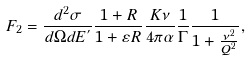Convert formula to latex. <formula><loc_0><loc_0><loc_500><loc_500>F _ { 2 } = \frac { d ^ { 2 } \sigma } { d \Omega d E ^ { ^ { \prime } } } \frac { 1 + R } { 1 + \varepsilon R } \frac { K \nu } { 4 \pi \alpha } \frac { 1 } { \Gamma } \frac { 1 } { 1 + \frac { \nu ^ { 2 } } { Q ^ { 2 } } } ,</formula> 